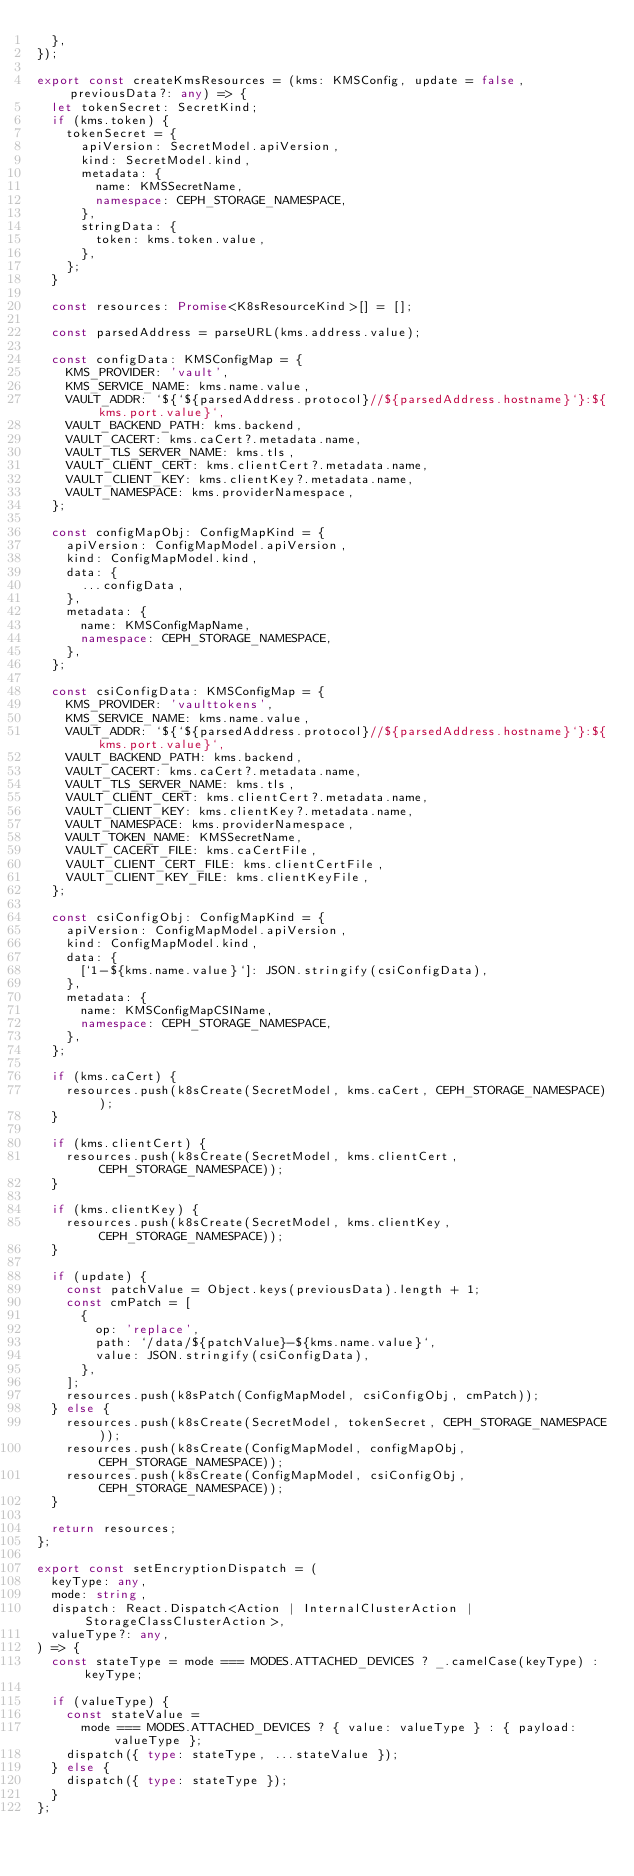Convert code to text. <code><loc_0><loc_0><loc_500><loc_500><_TypeScript_>  },
});

export const createKmsResources = (kms: KMSConfig, update = false, previousData?: any) => {
  let tokenSecret: SecretKind;
  if (kms.token) {
    tokenSecret = {
      apiVersion: SecretModel.apiVersion,
      kind: SecretModel.kind,
      metadata: {
        name: KMSSecretName,
        namespace: CEPH_STORAGE_NAMESPACE,
      },
      stringData: {
        token: kms.token.value,
      },
    };
  }

  const resources: Promise<K8sResourceKind>[] = [];

  const parsedAddress = parseURL(kms.address.value);

  const configData: KMSConfigMap = {
    KMS_PROVIDER: 'vault',
    KMS_SERVICE_NAME: kms.name.value,
    VAULT_ADDR: `${`${parsedAddress.protocol}//${parsedAddress.hostname}`}:${kms.port.value}`,
    VAULT_BACKEND_PATH: kms.backend,
    VAULT_CACERT: kms.caCert?.metadata.name,
    VAULT_TLS_SERVER_NAME: kms.tls,
    VAULT_CLIENT_CERT: kms.clientCert?.metadata.name,
    VAULT_CLIENT_KEY: kms.clientKey?.metadata.name,
    VAULT_NAMESPACE: kms.providerNamespace,
  };

  const configMapObj: ConfigMapKind = {
    apiVersion: ConfigMapModel.apiVersion,
    kind: ConfigMapModel.kind,
    data: {
      ...configData,
    },
    metadata: {
      name: KMSConfigMapName,
      namespace: CEPH_STORAGE_NAMESPACE,
    },
  };

  const csiConfigData: KMSConfigMap = {
    KMS_PROVIDER: 'vaulttokens',
    KMS_SERVICE_NAME: kms.name.value,
    VAULT_ADDR: `${`${parsedAddress.protocol}//${parsedAddress.hostname}`}:${kms.port.value}`,
    VAULT_BACKEND_PATH: kms.backend,
    VAULT_CACERT: kms.caCert?.metadata.name,
    VAULT_TLS_SERVER_NAME: kms.tls,
    VAULT_CLIENT_CERT: kms.clientCert?.metadata.name,
    VAULT_CLIENT_KEY: kms.clientKey?.metadata.name,
    VAULT_NAMESPACE: kms.providerNamespace,
    VAULT_TOKEN_NAME: KMSSecretName,
    VAULT_CACERT_FILE: kms.caCertFile,
    VAULT_CLIENT_CERT_FILE: kms.clientCertFile,
    VAULT_CLIENT_KEY_FILE: kms.clientKeyFile,
  };

  const csiConfigObj: ConfigMapKind = {
    apiVersion: ConfigMapModel.apiVersion,
    kind: ConfigMapModel.kind,
    data: {
      [`1-${kms.name.value}`]: JSON.stringify(csiConfigData),
    },
    metadata: {
      name: KMSConfigMapCSIName,
      namespace: CEPH_STORAGE_NAMESPACE,
    },
  };

  if (kms.caCert) {
    resources.push(k8sCreate(SecretModel, kms.caCert, CEPH_STORAGE_NAMESPACE));
  }

  if (kms.clientCert) {
    resources.push(k8sCreate(SecretModel, kms.clientCert, CEPH_STORAGE_NAMESPACE));
  }

  if (kms.clientKey) {
    resources.push(k8sCreate(SecretModel, kms.clientKey, CEPH_STORAGE_NAMESPACE));
  }

  if (update) {
    const patchValue = Object.keys(previousData).length + 1;
    const cmPatch = [
      {
        op: 'replace',
        path: `/data/${patchValue}-${kms.name.value}`,
        value: JSON.stringify(csiConfigData),
      },
    ];
    resources.push(k8sPatch(ConfigMapModel, csiConfigObj, cmPatch));
  } else {
    resources.push(k8sCreate(SecretModel, tokenSecret, CEPH_STORAGE_NAMESPACE));
    resources.push(k8sCreate(ConfigMapModel, configMapObj, CEPH_STORAGE_NAMESPACE));
    resources.push(k8sCreate(ConfigMapModel, csiConfigObj, CEPH_STORAGE_NAMESPACE));
  }

  return resources;
};

export const setEncryptionDispatch = (
  keyType: any,
  mode: string,
  dispatch: React.Dispatch<Action | InternalClusterAction | StorageClassClusterAction>,
  valueType?: any,
) => {
  const stateType = mode === MODES.ATTACHED_DEVICES ? _.camelCase(keyType) : keyType;

  if (valueType) {
    const stateValue =
      mode === MODES.ATTACHED_DEVICES ? { value: valueType } : { payload: valueType };
    dispatch({ type: stateType, ...stateValue });
  } else {
    dispatch({ type: stateType });
  }
};
</code> 